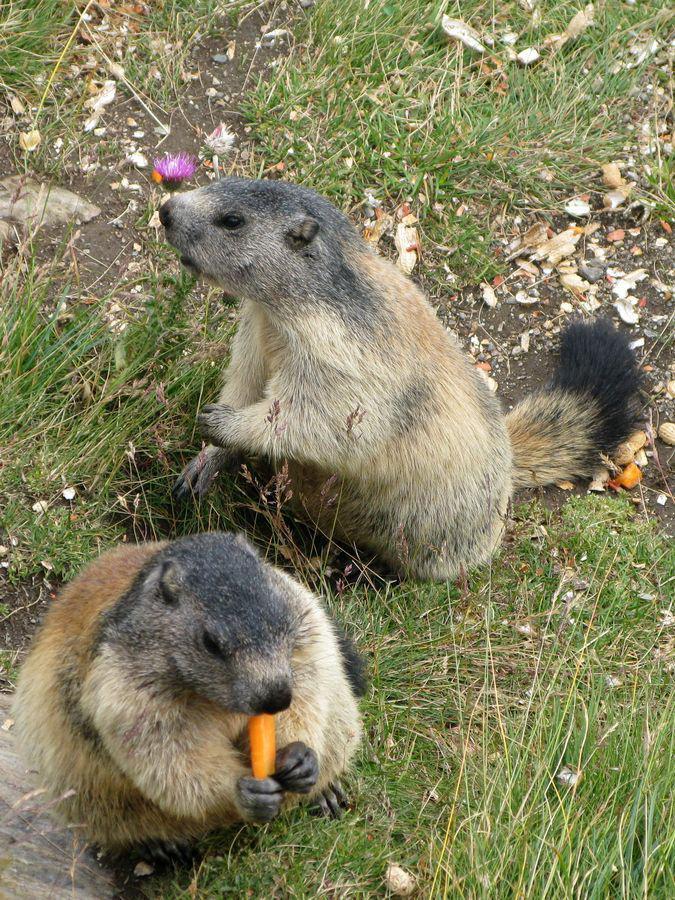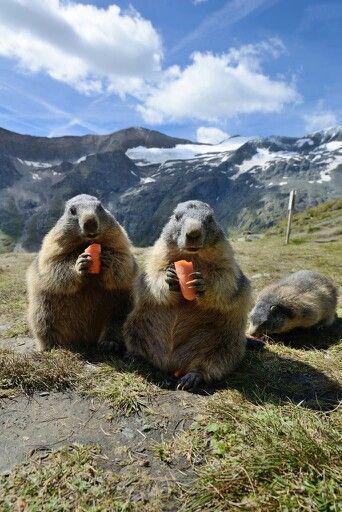The first image is the image on the left, the second image is the image on the right. Examine the images to the left and right. Is the description "Two marmots are in contact in a nuzzling pose in one image." accurate? Answer yes or no. No. 